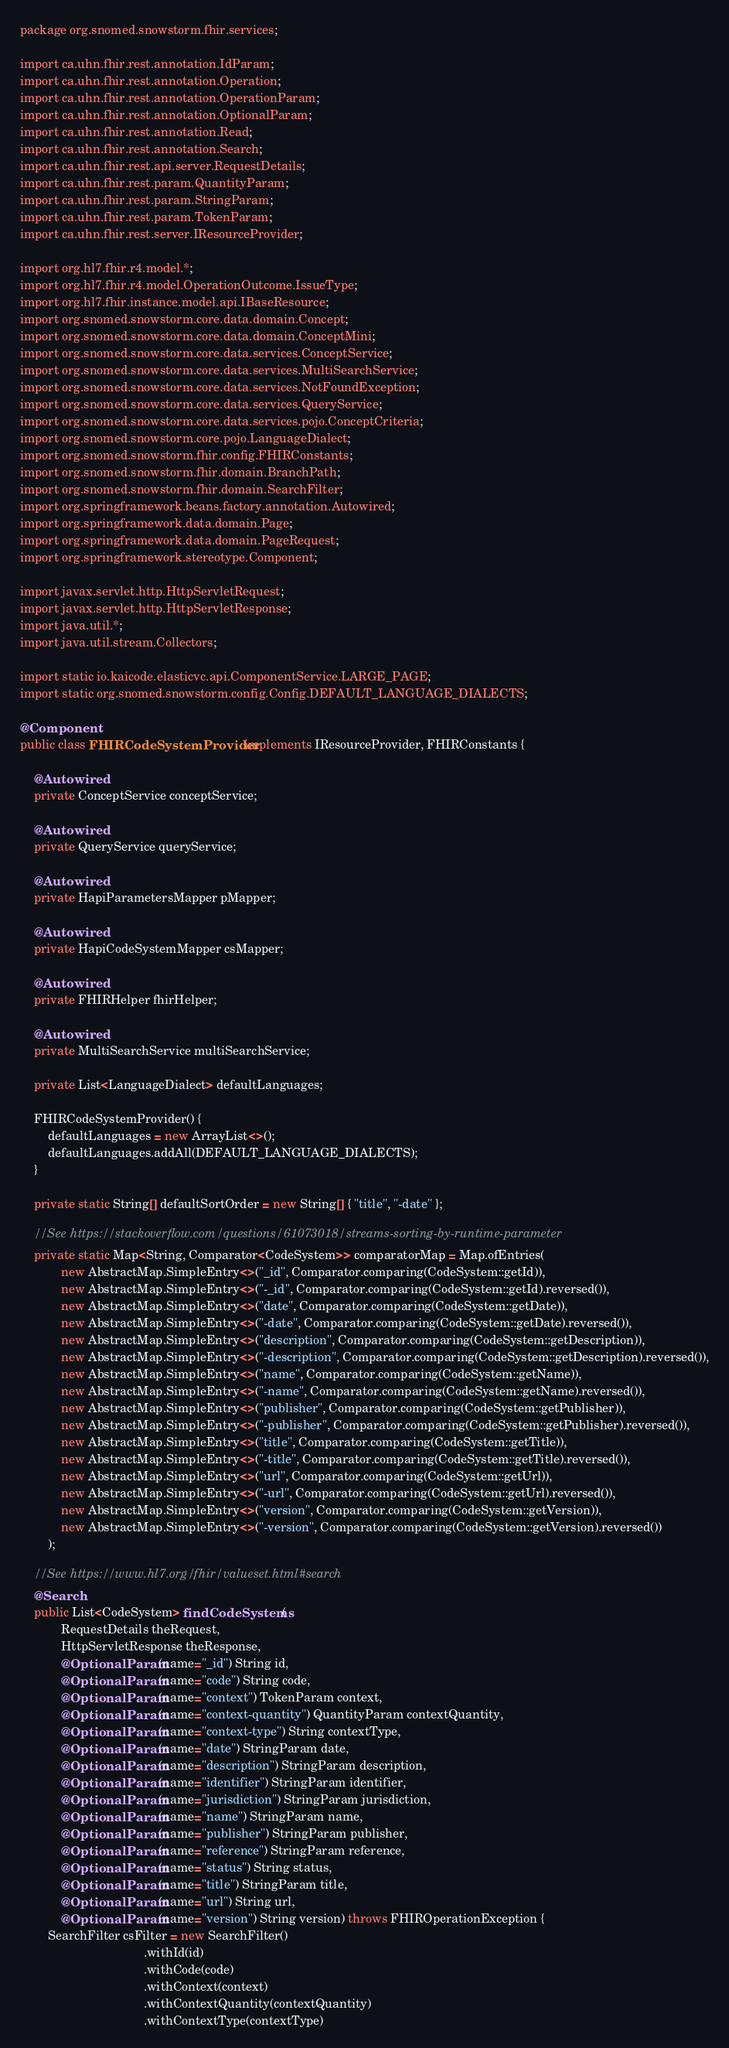Convert code to text. <code><loc_0><loc_0><loc_500><loc_500><_Java_>package org.snomed.snowstorm.fhir.services;

import ca.uhn.fhir.rest.annotation.IdParam;
import ca.uhn.fhir.rest.annotation.Operation;
import ca.uhn.fhir.rest.annotation.OperationParam;
import ca.uhn.fhir.rest.annotation.OptionalParam;
import ca.uhn.fhir.rest.annotation.Read;
import ca.uhn.fhir.rest.annotation.Search;
import ca.uhn.fhir.rest.api.server.RequestDetails;
import ca.uhn.fhir.rest.param.QuantityParam;
import ca.uhn.fhir.rest.param.StringParam;
import ca.uhn.fhir.rest.param.TokenParam;
import ca.uhn.fhir.rest.server.IResourceProvider;

import org.hl7.fhir.r4.model.*;
import org.hl7.fhir.r4.model.OperationOutcome.IssueType;
import org.hl7.fhir.instance.model.api.IBaseResource;
import org.snomed.snowstorm.core.data.domain.Concept;
import org.snomed.snowstorm.core.data.domain.ConceptMini;
import org.snomed.snowstorm.core.data.services.ConceptService;
import org.snomed.snowstorm.core.data.services.MultiSearchService;
import org.snomed.snowstorm.core.data.services.NotFoundException;
import org.snomed.snowstorm.core.data.services.QueryService;
import org.snomed.snowstorm.core.data.services.pojo.ConceptCriteria;
import org.snomed.snowstorm.core.pojo.LanguageDialect;
import org.snomed.snowstorm.fhir.config.FHIRConstants;
import org.snomed.snowstorm.fhir.domain.BranchPath;
import org.snomed.snowstorm.fhir.domain.SearchFilter;
import org.springframework.beans.factory.annotation.Autowired;
import org.springframework.data.domain.Page;
import org.springframework.data.domain.PageRequest;
import org.springframework.stereotype.Component;

import javax.servlet.http.HttpServletRequest;
import javax.servlet.http.HttpServletResponse;
import java.util.*;
import java.util.stream.Collectors;

import static io.kaicode.elasticvc.api.ComponentService.LARGE_PAGE;
import static org.snomed.snowstorm.config.Config.DEFAULT_LANGUAGE_DIALECTS;

@Component
public class FHIRCodeSystemProvider implements IResourceProvider, FHIRConstants {

	@Autowired
	private ConceptService conceptService;

	@Autowired
	private QueryService queryService;

	@Autowired
	private HapiParametersMapper pMapper;
	
	@Autowired
	private HapiCodeSystemMapper csMapper;
	
	@Autowired
	private FHIRHelper fhirHelper;

	@Autowired
	private MultiSearchService multiSearchService;
	
	private List<LanguageDialect> defaultLanguages;
	
	FHIRCodeSystemProvider() {
		defaultLanguages = new ArrayList<>();
		defaultLanguages.addAll(DEFAULT_LANGUAGE_DIALECTS);
	}
	
	private static String[] defaultSortOrder = new String[] { "title", "-date" };
	
	//See https://stackoverflow.com/questions/61073018/streams-sorting-by-runtime-parameter
	private static Map<String, Comparator<CodeSystem>> comparatorMap = Map.ofEntries(
			new AbstractMap.SimpleEntry<>("_id", Comparator.comparing(CodeSystem::getId)),
			new AbstractMap.SimpleEntry<>("-_id", Comparator.comparing(CodeSystem::getId).reversed()),
			new AbstractMap.SimpleEntry<>("date", Comparator.comparing(CodeSystem::getDate)),
			new AbstractMap.SimpleEntry<>("-date", Comparator.comparing(CodeSystem::getDate).reversed()),
			new AbstractMap.SimpleEntry<>("description", Comparator.comparing(CodeSystem::getDescription)),
			new AbstractMap.SimpleEntry<>("-description", Comparator.comparing(CodeSystem::getDescription).reversed()),
			new AbstractMap.SimpleEntry<>("name", Comparator.comparing(CodeSystem::getName)),
			new AbstractMap.SimpleEntry<>("-name", Comparator.comparing(CodeSystem::getName).reversed()),
			new AbstractMap.SimpleEntry<>("publisher", Comparator.comparing(CodeSystem::getPublisher)),
			new AbstractMap.SimpleEntry<>("-publisher", Comparator.comparing(CodeSystem::getPublisher).reversed()),
			new AbstractMap.SimpleEntry<>("title", Comparator.comparing(CodeSystem::getTitle)),
			new AbstractMap.SimpleEntry<>("-title", Comparator.comparing(CodeSystem::getTitle).reversed()),
			new AbstractMap.SimpleEntry<>("url", Comparator.comparing(CodeSystem::getUrl)),
			new AbstractMap.SimpleEntry<>("-url", Comparator.comparing(CodeSystem::getUrl).reversed()),
			new AbstractMap.SimpleEntry<>("version", Comparator.comparing(CodeSystem::getVersion)),
			new AbstractMap.SimpleEntry<>("-version", Comparator.comparing(CodeSystem::getVersion).reversed())
		);
	
	//See https://www.hl7.org/fhir/valueset.html#search
	@Search
	public List<CodeSystem> findCodeSystems(
			RequestDetails theRequest, 
			HttpServletResponse theResponse,
			@OptionalParam(name="_id") String id,
			@OptionalParam(name="code") String code,
			@OptionalParam(name="context") TokenParam context,
			@OptionalParam(name="context-quantity") QuantityParam contextQuantity,
			@OptionalParam(name="context-type") String contextType,
			@OptionalParam(name="date") StringParam date,
			@OptionalParam(name="description") StringParam description,
			@OptionalParam(name="identifier") StringParam identifier,
			@OptionalParam(name="jurisdiction") StringParam jurisdiction,
			@OptionalParam(name="name") StringParam name,
			@OptionalParam(name="publisher") StringParam publisher,
			@OptionalParam(name="reference") StringParam reference,
			@OptionalParam(name="status") String status,
			@OptionalParam(name="title") StringParam title,
			@OptionalParam(name="url") String url,
			@OptionalParam(name="version") String version) throws FHIROperationException {
		SearchFilter csFilter = new SearchFilter()
									.withId(id)
									.withCode(code)
									.withContext(context)
									.withContextQuantity(contextQuantity)
									.withContextType(contextType)</code> 